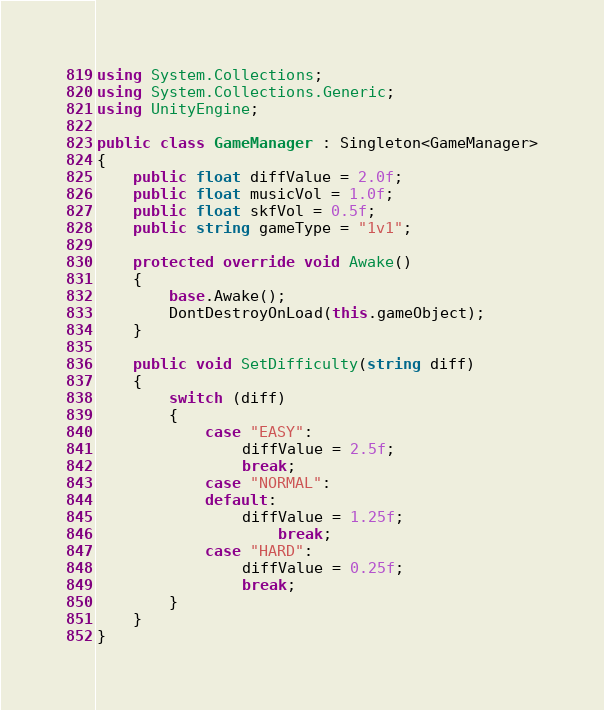<code> <loc_0><loc_0><loc_500><loc_500><_C#_>using System.Collections;
using System.Collections.Generic;
using UnityEngine;

public class GameManager : Singleton<GameManager>
{
    public float diffValue = 2.0f;
    public float musicVol = 1.0f;
    public float skfVol = 0.5f;
    public string gameType = "1v1";

    protected override void Awake()
    {
        base.Awake();
        DontDestroyOnLoad(this.gameObject);
    }

    public void SetDifficulty(string diff)
    {
        switch (diff)
        {
            case "EASY":
                diffValue = 2.5f;
                break;
            case "NORMAL":
            default:
                diffValue = 1.25f;
                    break;
            case "HARD":
                diffValue = 0.25f;
                break;
        }
    }
}
</code> 